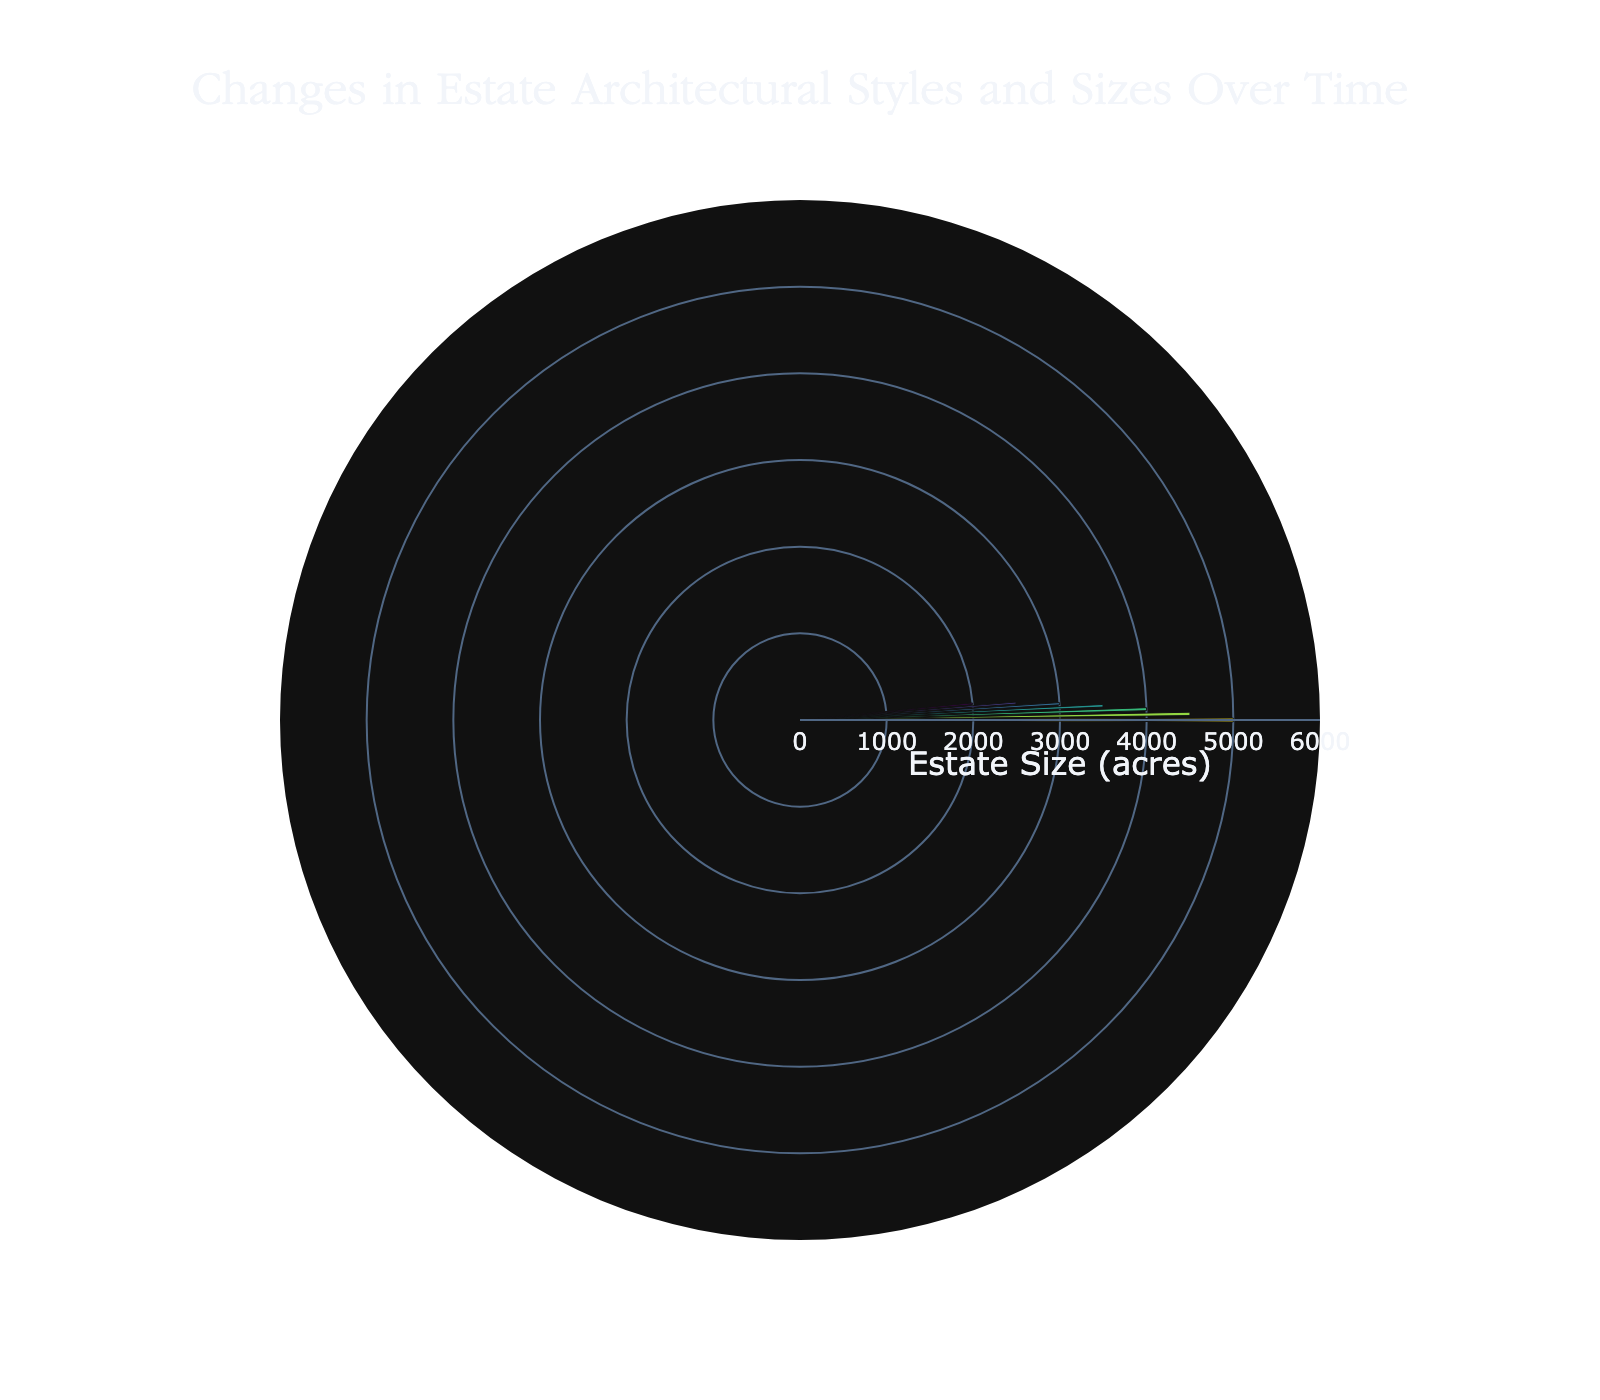What is the title of the chart? The title of the chart is visible at the top and it reads: 'Changes in Estate Architectural Styles and Sizes Over Time'.
Answer: Changes in Estate Architectural Styles and Sizes Over Time How many different architectural styles are shown in the chart? The chart displays different colors and slices for each time period, corresponding to distinct architectural styles. Counting them gives 7 styles.
Answer: 7 Which architectural style corresponds to the smallest average estate size? Each style links to an estate size, and from the innermost part of the fan chart, the smallest size is associated with the Contemporary style.
Answer: Contemporary What is the range of average estate sizes depicted in the chart? The outermost slice shows the largest size (5000 acres), and the innermost slice shows the smallest size (2000 acres). The range is calculated as 5000 - 2000.
Answer: 3000 What is the average estate size for the Victorian period? Locate the Victorian period in the labeled slices of the fan chart and refer to the corresponding estate size.
Answer: 3500 acres Which time period has the most significant reduction in estate size compared to the previous period? Analyze each period's estate size drop compared to the preceding period: 
- 1750-1800: 500 acres 
- 1800-1850: 500 acres 
- 1850-1900: 500 acres 
- 1900-1950: 500 acres 
- 1950-2000: 500 acres 
- 2000-Present: 500 acres. All have the same reduction, 500 acres.
Answer: All equal at 500 acres Which two periods have a combined average estate size larger than 7000 acres? Sum the sizes for each combination and find the pair that exceeds 7000:
- 1700-1750 (5000) + 1750-1800 (4500) = 9500 acres
- Other combinations are smaller.
Thus, 1700-1750 and 1750-1800 combined exceed 7000 acres.
Answer: 1700-1750 and 1750-1800 By how much did the average estate size decrease from the Neoclassical to Edwardian periods? Find the sizes for Neoclassical (4000 acres) and Edwardian (3000 acres), then subtract to find difference: 4000 - 3000.
Answer: 1000 acres Which architectural style has an estate size closest to the median estate size in the chart? List sizes: 5000, 4500, 4000, 3500, 3000, 2500, 2000. The median, being the fourth value when ordered: 3500 acres corresponds to Victorian style.
Answer: Victorian Which architectural style showed the highest average estate size? Identify the peak value on the radial axis, which belongs to the style at the outermost position of the chart, corresponding to the Baroque period.
Answer: Baroque 